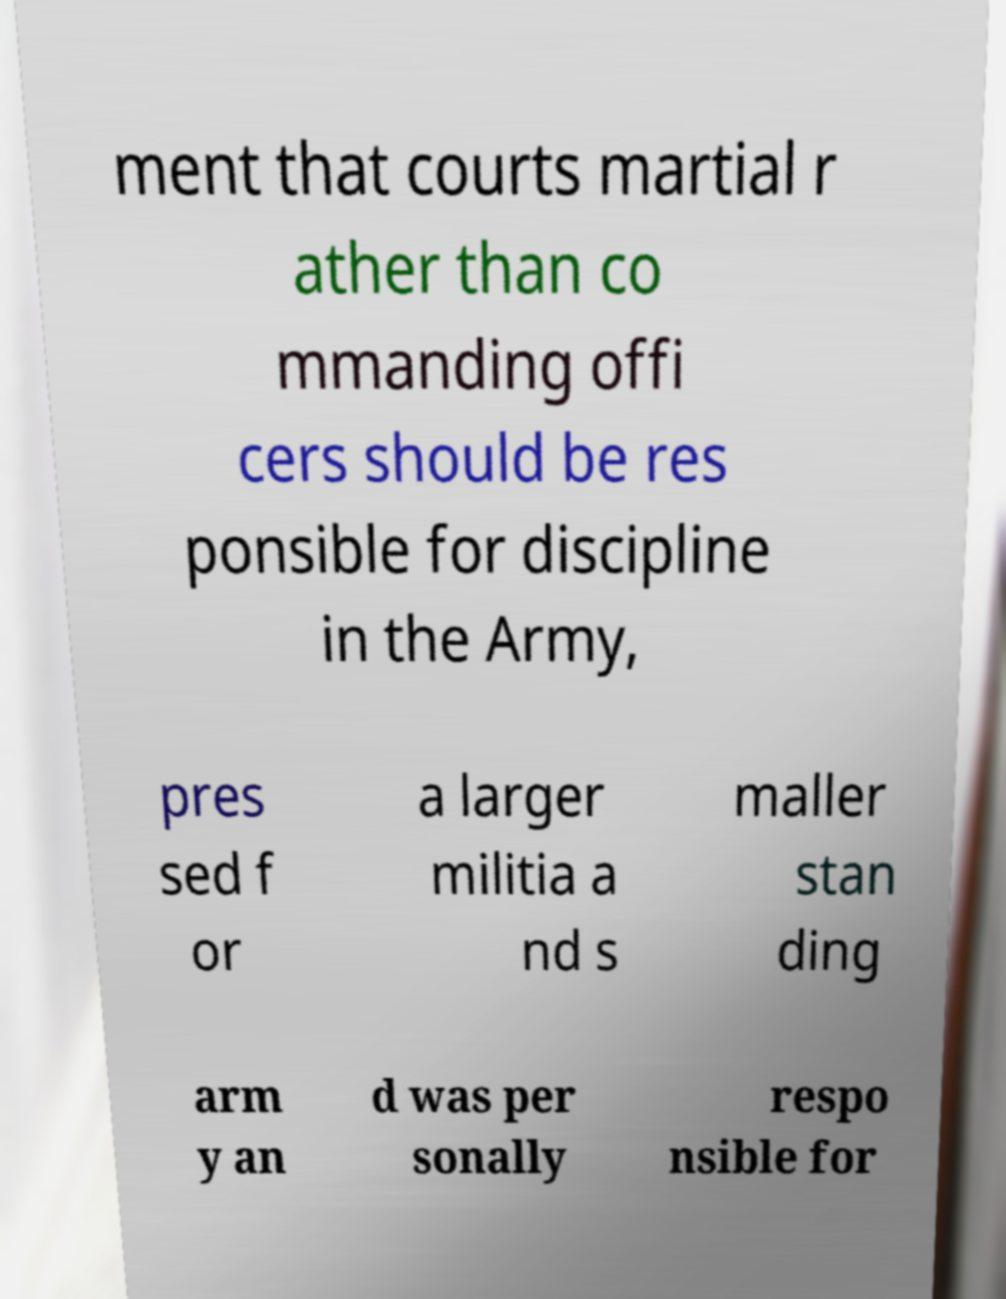I need the written content from this picture converted into text. Can you do that? ment that courts martial r ather than co mmanding offi cers should be res ponsible for discipline in the Army, pres sed f or a larger militia a nd s maller stan ding arm y an d was per sonally respo nsible for 